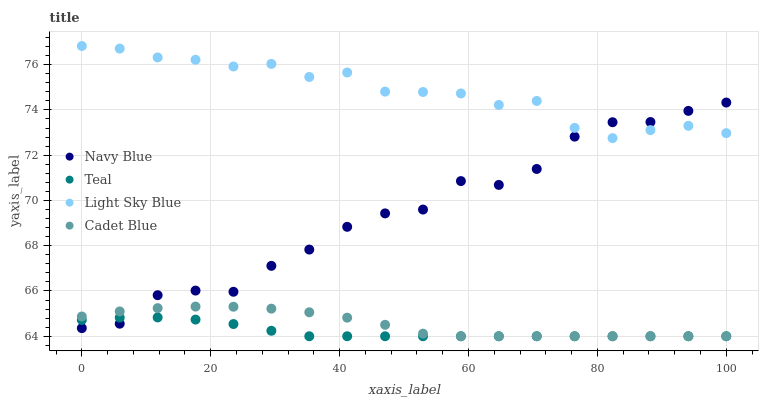Does Teal have the minimum area under the curve?
Answer yes or no. Yes. Does Light Sky Blue have the maximum area under the curve?
Answer yes or no. Yes. Does Navy Blue have the minimum area under the curve?
Answer yes or no. No. Does Navy Blue have the maximum area under the curve?
Answer yes or no. No. Is Teal the smoothest?
Answer yes or no. Yes. Is Navy Blue the roughest?
Answer yes or no. Yes. Is Light Sky Blue the smoothest?
Answer yes or no. No. Is Light Sky Blue the roughest?
Answer yes or no. No. Does Cadet Blue have the lowest value?
Answer yes or no. Yes. Does Navy Blue have the lowest value?
Answer yes or no. No. Does Light Sky Blue have the highest value?
Answer yes or no. Yes. Does Navy Blue have the highest value?
Answer yes or no. No. Is Cadet Blue less than Light Sky Blue?
Answer yes or no. Yes. Is Light Sky Blue greater than Cadet Blue?
Answer yes or no. Yes. Does Light Sky Blue intersect Navy Blue?
Answer yes or no. Yes. Is Light Sky Blue less than Navy Blue?
Answer yes or no. No. Is Light Sky Blue greater than Navy Blue?
Answer yes or no. No. Does Cadet Blue intersect Light Sky Blue?
Answer yes or no. No. 